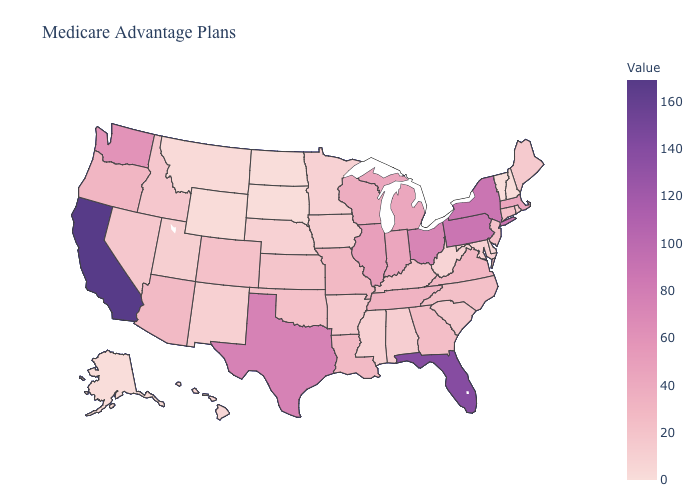Which states hav the highest value in the South?
Concise answer only. Florida. Does California have the highest value in the USA?
Concise answer only. Yes. 